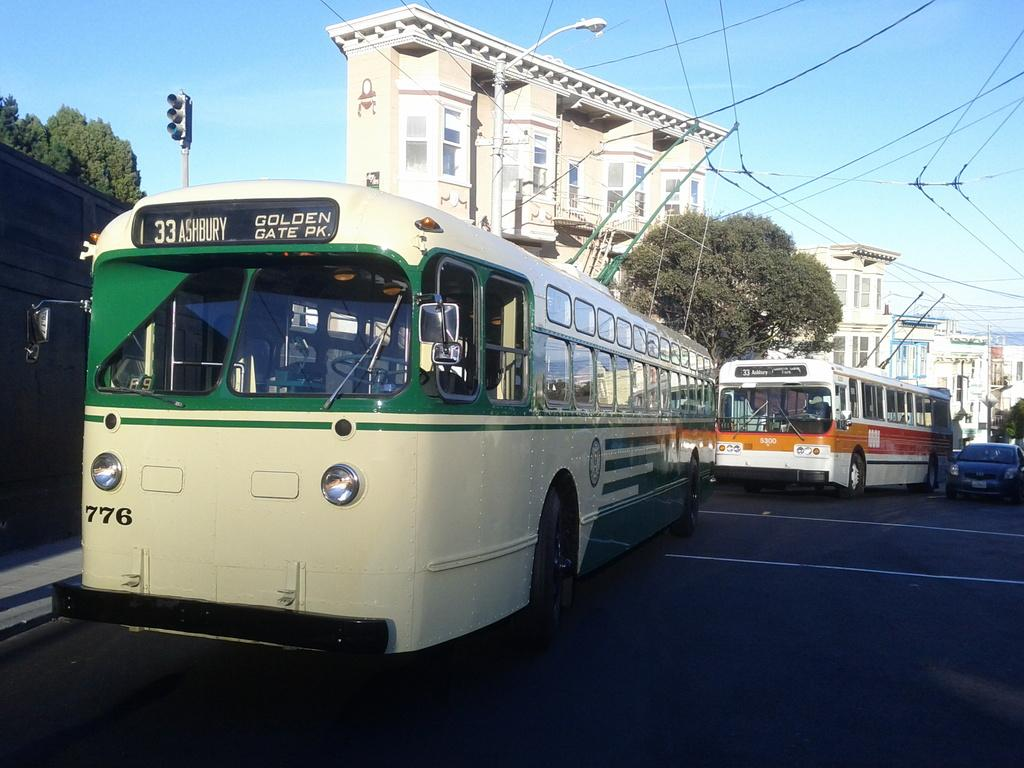What types of vehicles are present in the image? There are buses and a car in the image. What are the vehicles doing in the image? The vehicles are moving on a road. What else can be seen in the image besides the vehicles? There are buildings, trees, a pole light, and a traffic signal pole in the image. How would you describe the sky in the image? The sky is blue and cloudy. What type of music can be heard coming from the car in the image? There is no indication in the image that music is playing in the car, so it's not possible to determine what, if any, music might be heard. 